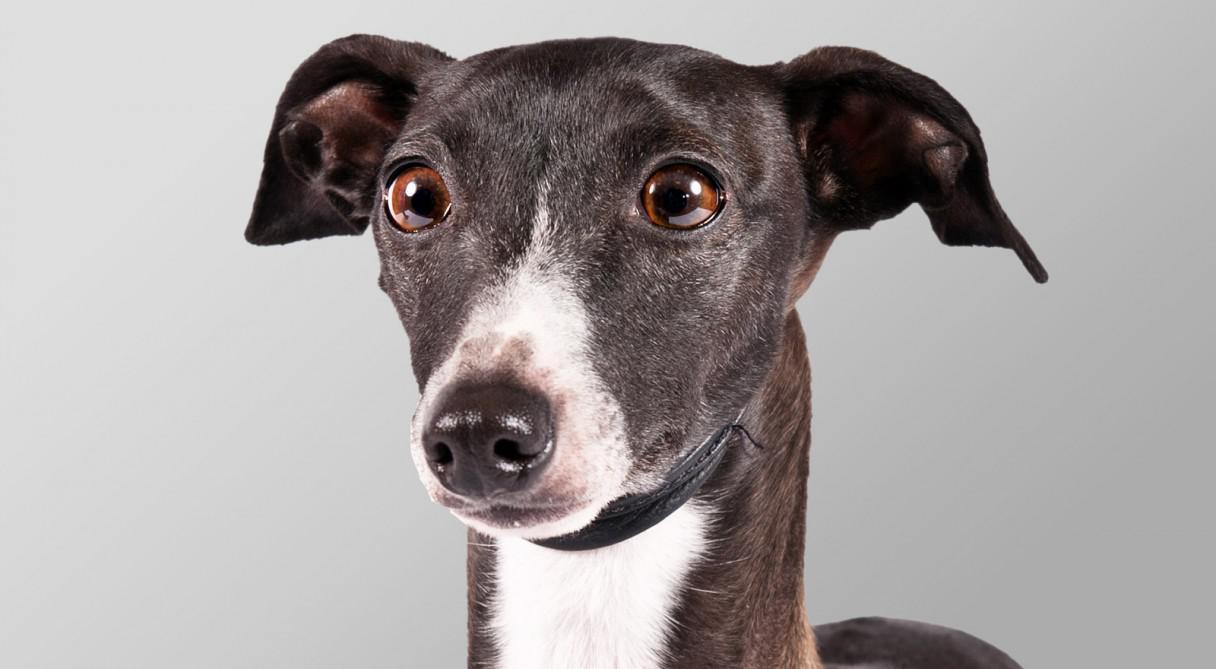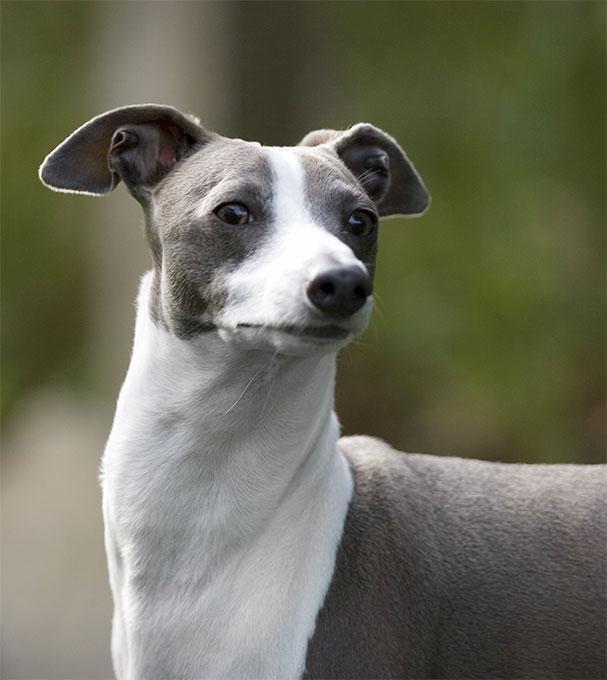The first image is the image on the left, the second image is the image on the right. Assess this claim about the two images: "Exactly one dog wears a bright red collar.". Correct or not? Answer yes or no. No. The first image is the image on the left, the second image is the image on the right. Given the left and right images, does the statement "A grayish hound with white chest marking is wearing a bright red collar." hold true? Answer yes or no. No. 